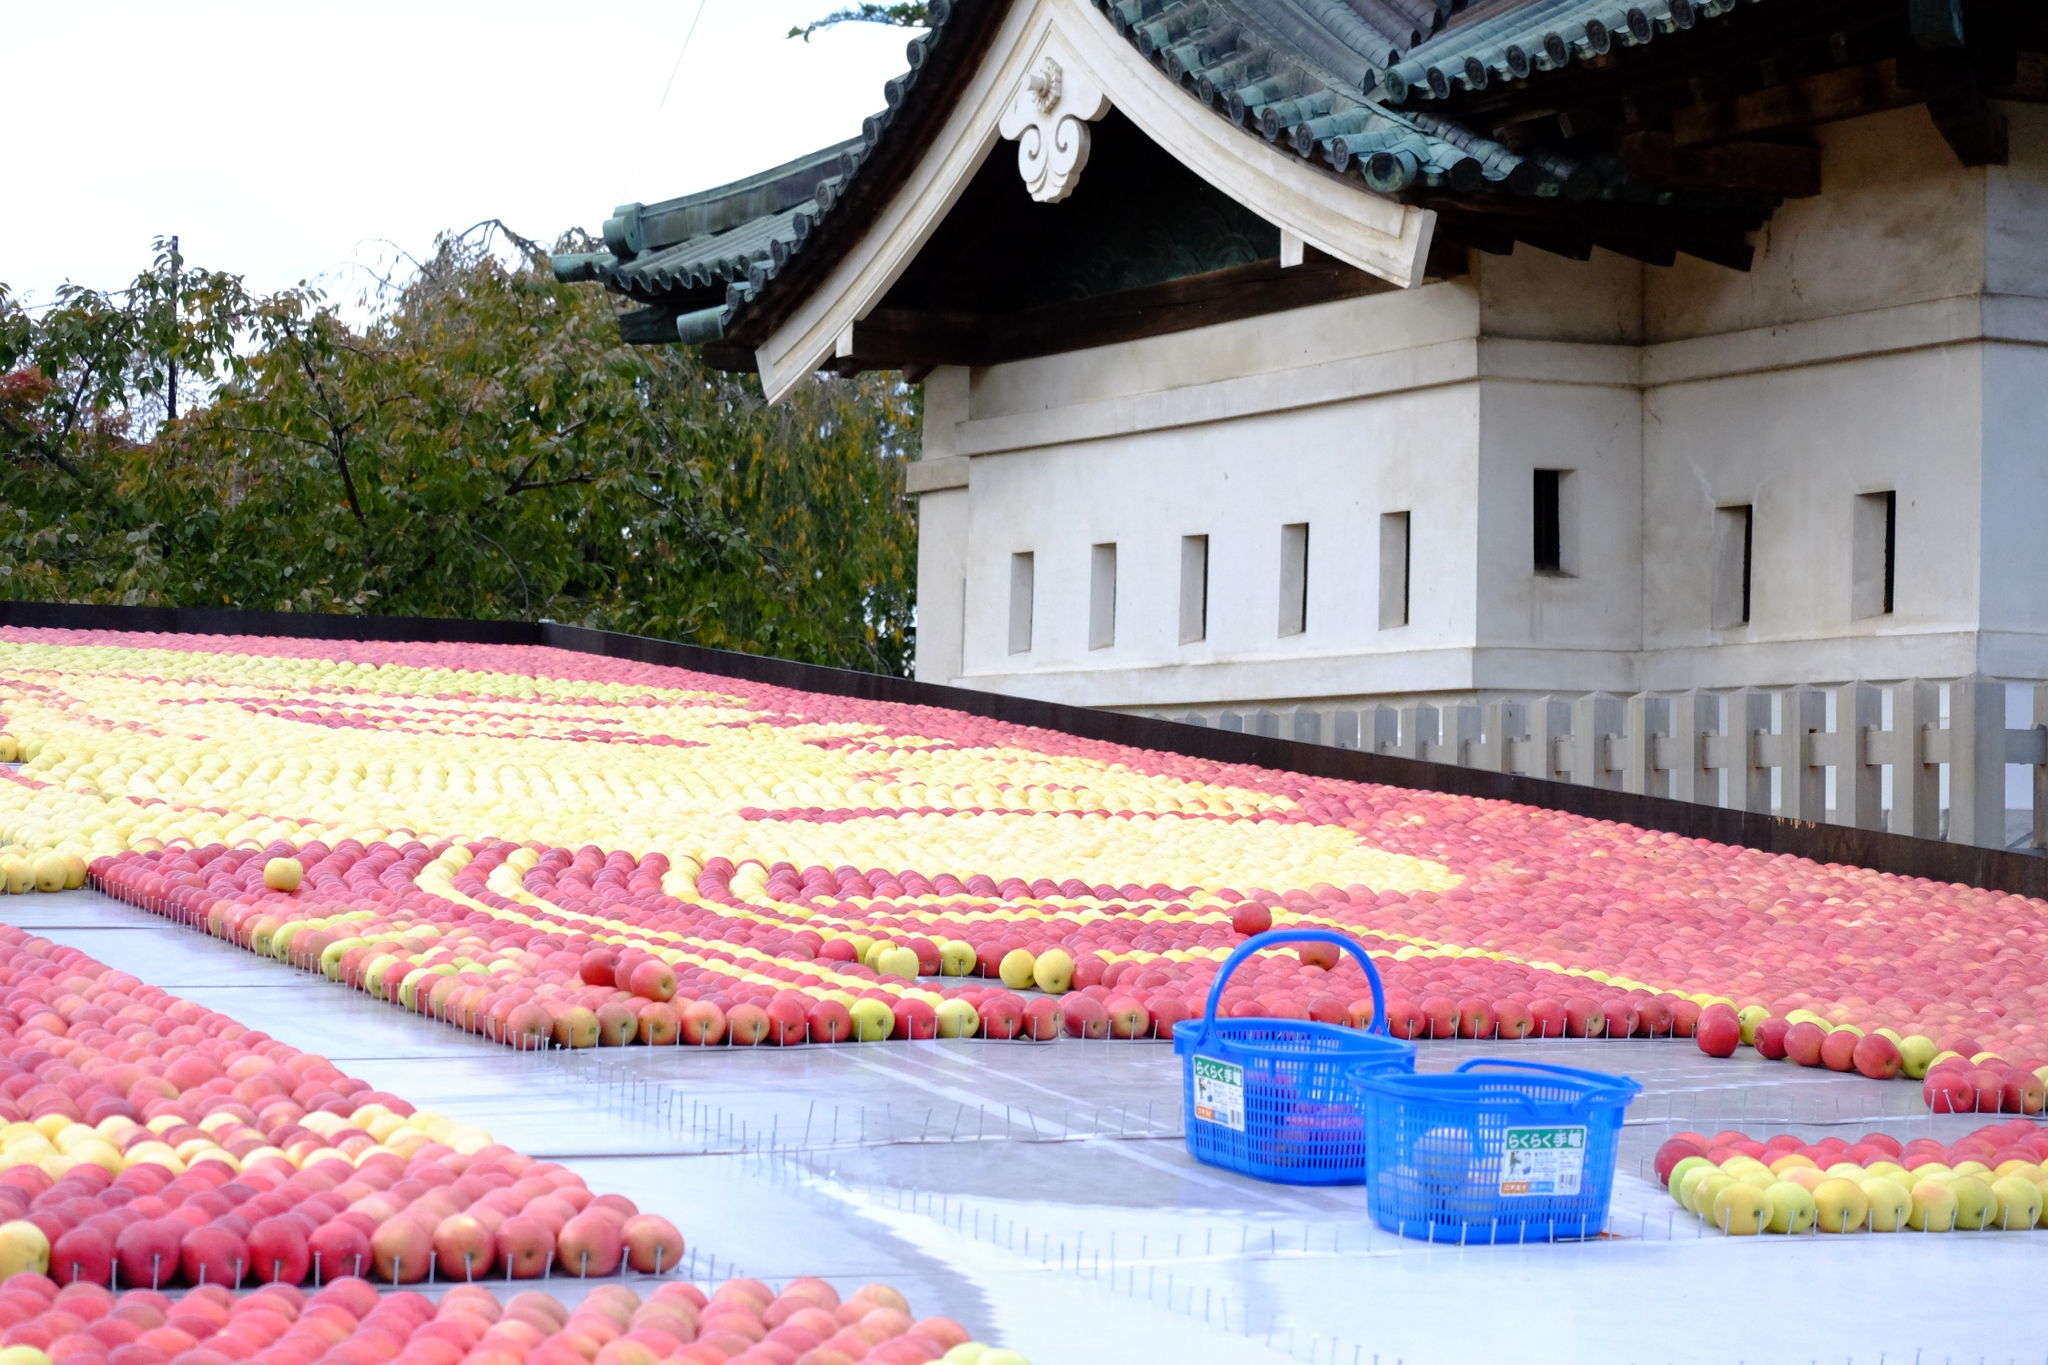Can you tell me more about why there are so many apples arranged in this way? These apples are likely arranged for a specific local festival or agricultural event in Japan, such as an apple harvest festival. The meticulous arrangement and sheer quantity suggest a celebration of the apple crop, possibly a display contest where growers showcase their best produce to the public. Events like this can foster community spirit and celebrate local agriculture, emphasizing the importance of apple growing in the region. What does the arrangement of the apples signify? The specific pattern in which the apples are arranged may have cultural significance, symbolizing prosperity, harmony, or gratitude for a bountiful harvest. In many cultures, circular patterns are associated with unity and the cycle of life, which could be reflected here. The event likely incorporates traditional values or beliefs, making the arrangement not just artistic, but also meaningful to the participants and viewers. 